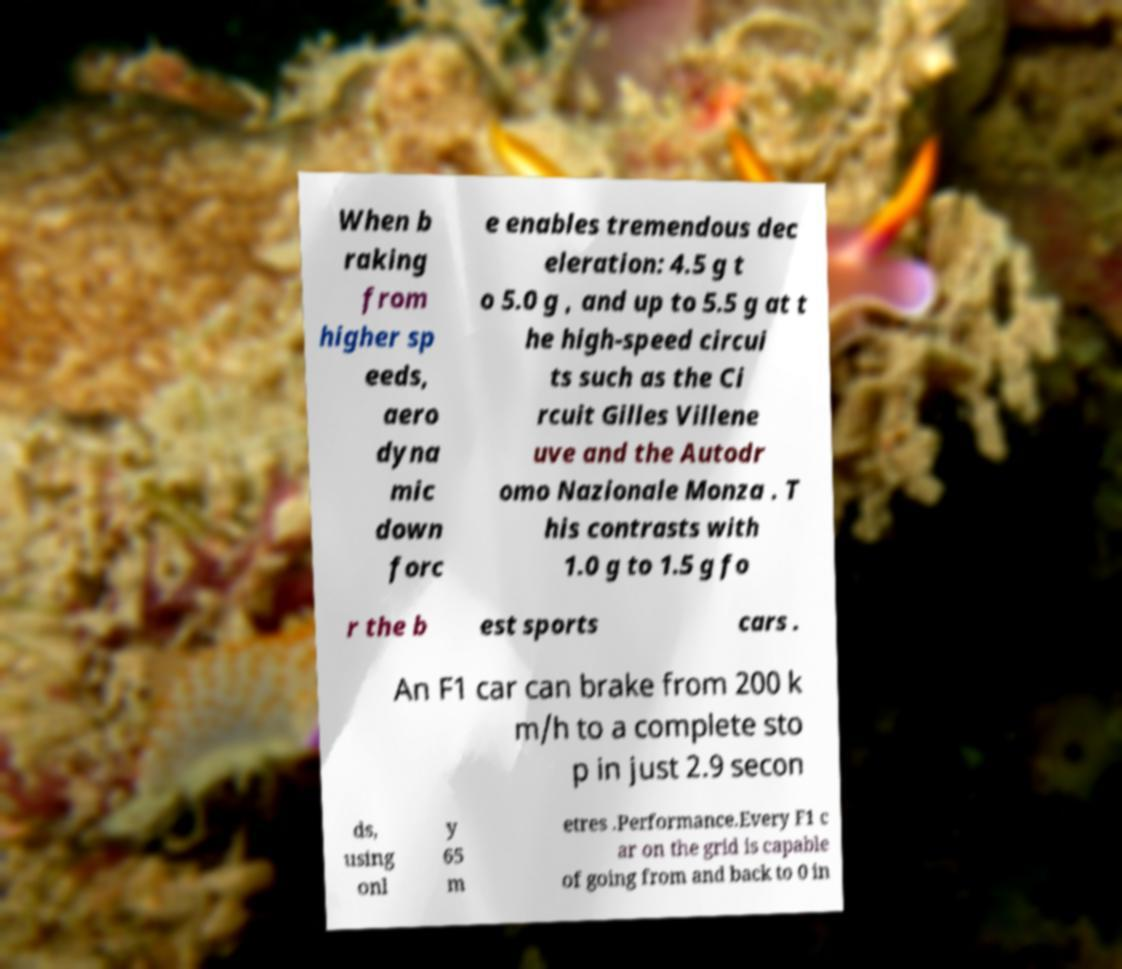Could you extract and type out the text from this image? When b raking from higher sp eeds, aero dyna mic down forc e enables tremendous dec eleration: 4.5 g t o 5.0 g , and up to 5.5 g at t he high-speed circui ts such as the Ci rcuit Gilles Villene uve and the Autodr omo Nazionale Monza . T his contrasts with 1.0 g to 1.5 g fo r the b est sports cars . An F1 car can brake from 200 k m/h to a complete sto p in just 2.9 secon ds, using onl y 65 m etres .Performance.Every F1 c ar on the grid is capable of going from and back to 0 in 